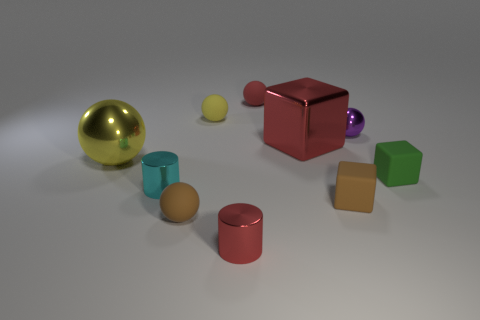There is a object that is the same color as the large ball; what shape is it?
Provide a short and direct response. Sphere. Are there any other things that are the same color as the metal block?
Give a very brief answer. Yes. What is the shape of the red metallic thing behind the yellow metallic sphere?
Your answer should be compact. Cube. Do the big block and the metal cylinder that is behind the small red metal thing have the same color?
Your answer should be compact. No. Is the number of small red shiny cylinders behind the purple thing the same as the number of small yellow matte things in front of the tiny green matte block?
Keep it short and to the point. Yes. What number of other objects are the same size as the green matte thing?
Provide a short and direct response. 7. How big is the brown sphere?
Your response must be concise. Small. Are the green cube and the small red object that is behind the yellow shiny object made of the same material?
Your response must be concise. Yes. Are there any tiny red metallic objects that have the same shape as the tiny cyan object?
Your answer should be compact. Yes. There is a red cylinder that is the same size as the brown ball; what material is it?
Give a very brief answer. Metal. 